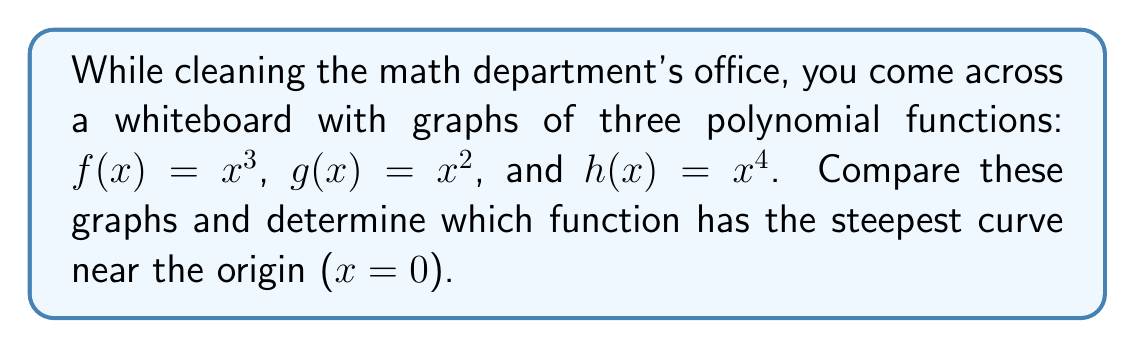Provide a solution to this math problem. Let's approach this step-by-step:

1) First, recall that the steepness of a curve at a point is related to its derivative at that point. The greater the absolute value of the derivative, the steeper the curve.

2) Let's find the derivatives of each function:
   $f'(x) = 3x^2$
   $g'(x) = 2x$
   $h'(x) = 4x^3$

3) Now, we need to evaluate these derivatives at x = 0:
   $f'(0) = 3(0)^2 = 0$
   $g'(0) = 2(0) = 0$
   $h'(0) = 4(0)^3 = 0$

4) All derivatives equal zero at x = 0, which means all curves pass through the origin with a horizontal tangent line.

5) To determine which is steepest near (but not at) the origin, we need to look at how quickly the derivatives change as we move away from x = 0.

6) Let's compare the second derivatives:
   $f''(x) = 6x$
   $g''(x) = 2$
   $h''(x) = 12x^2$

7) At x = 0:
   $f''(0) = 0$
   $g''(0) = 2$
   $h''(0) = 0$

8) The quadratic function $g(x) = x^2$ has a constant, non-zero second derivative. This means it curves away from its tangent line more quickly than the other functions near x = 0.

Therefore, $g(x) = x^2$ has the steepest curve near the origin.
Answer: $g(x) = x^2$ 